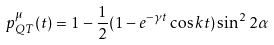Convert formula to latex. <formula><loc_0><loc_0><loc_500><loc_500>p _ { Q T } ^ { \mu } ( t ) = 1 - \frac { 1 } { 2 } ( 1 - e ^ { - \gamma t } \cos k t ) \sin ^ { 2 } 2 \alpha</formula> 